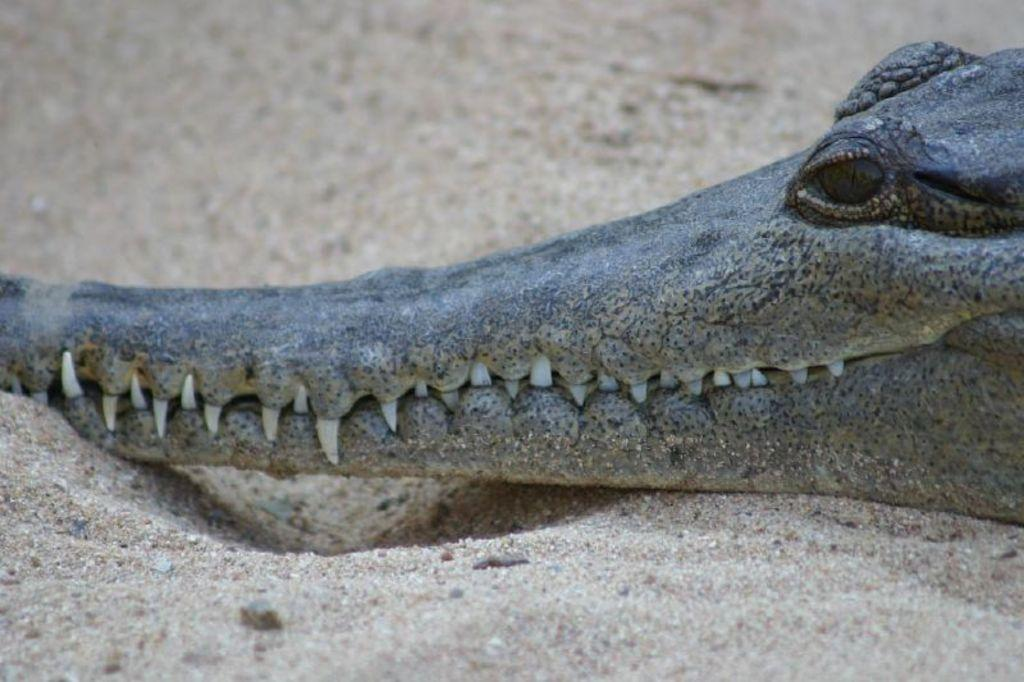What animal is present in the image? There is a crocodile in the image. What type of terrain is the crocodile on? The crocodile is on the sand. How many pairs of shoes can be seen on the crocodile in the image? There are no shoes present on the crocodile in the image. 